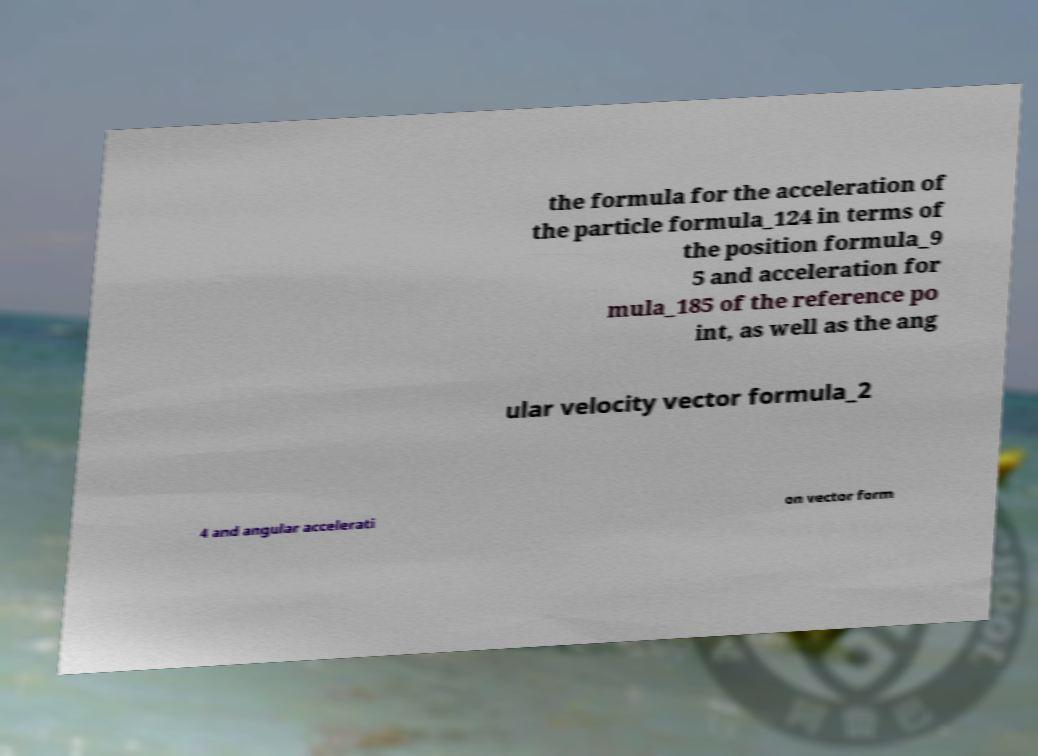Please read and relay the text visible in this image. What does it say? the formula for the acceleration of the particle formula_124 in terms of the position formula_9 5 and acceleration for mula_185 of the reference po int, as well as the ang ular velocity vector formula_2 4 and angular accelerati on vector form 